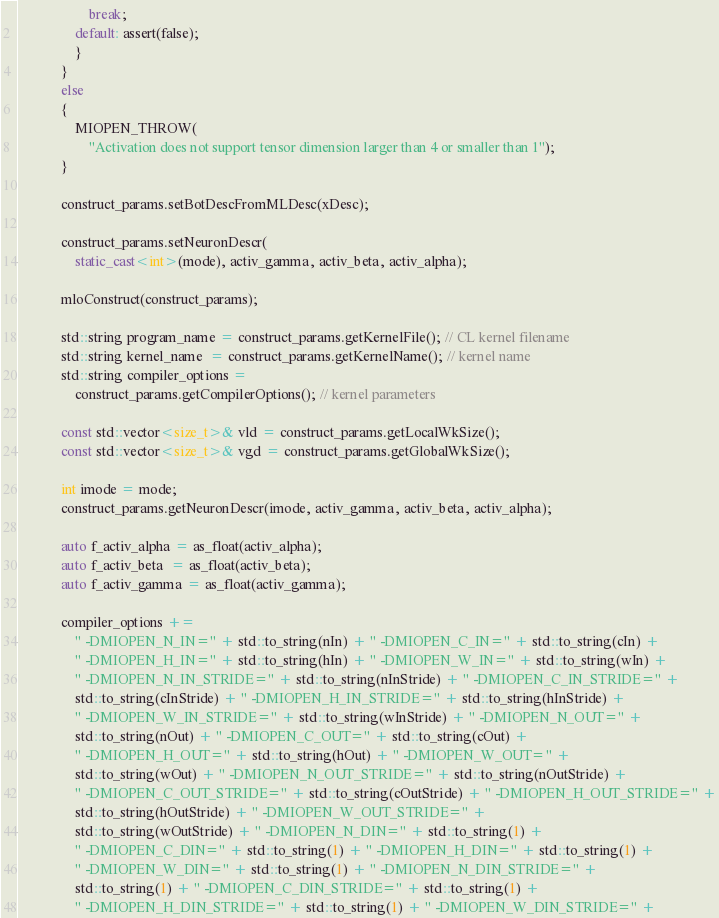<code> <loc_0><loc_0><loc_500><loc_500><_C++_>                    break;
                default: assert(false);
                }
            }
            else
            {
                MIOPEN_THROW(
                    "Activation does not support tensor dimension larger than 4 or smaller than 1");
            }

            construct_params.setBotDescFromMLDesc(xDesc);

            construct_params.setNeuronDescr(
                static_cast<int>(mode), activ_gamma, activ_beta, activ_alpha);

            mloConstruct(construct_params);

            std::string program_name = construct_params.getKernelFile(); // CL kernel filename
            std::string kernel_name  = construct_params.getKernelName(); // kernel name
            std::string compiler_options =
                construct_params.getCompilerOptions(); // kernel parameters

            const std::vector<size_t>& vld = construct_params.getLocalWkSize();
            const std::vector<size_t>& vgd = construct_params.getGlobalWkSize();

            int imode = mode;
            construct_params.getNeuronDescr(imode, activ_gamma, activ_beta, activ_alpha);

            auto f_activ_alpha = as_float(activ_alpha);
            auto f_activ_beta  = as_float(activ_beta);
            auto f_activ_gamma = as_float(activ_gamma);

            compiler_options +=
                " -DMIOPEN_N_IN=" + std::to_string(nIn) + " -DMIOPEN_C_IN=" + std::to_string(cIn) +
                " -DMIOPEN_H_IN=" + std::to_string(hIn) + " -DMIOPEN_W_IN=" + std::to_string(wIn) +
                " -DMIOPEN_N_IN_STRIDE=" + std::to_string(nInStride) + " -DMIOPEN_C_IN_STRIDE=" +
                std::to_string(cInStride) + " -DMIOPEN_H_IN_STRIDE=" + std::to_string(hInStride) +
                " -DMIOPEN_W_IN_STRIDE=" + std::to_string(wInStride) + " -DMIOPEN_N_OUT=" +
                std::to_string(nOut) + " -DMIOPEN_C_OUT=" + std::to_string(cOut) +
                " -DMIOPEN_H_OUT=" + std::to_string(hOut) + " -DMIOPEN_W_OUT=" +
                std::to_string(wOut) + " -DMIOPEN_N_OUT_STRIDE=" + std::to_string(nOutStride) +
                " -DMIOPEN_C_OUT_STRIDE=" + std::to_string(cOutStride) + " -DMIOPEN_H_OUT_STRIDE=" +
                std::to_string(hOutStride) + " -DMIOPEN_W_OUT_STRIDE=" +
                std::to_string(wOutStride) + " -DMIOPEN_N_DIN=" + std::to_string(1) +
                " -DMIOPEN_C_DIN=" + std::to_string(1) + " -DMIOPEN_H_DIN=" + std::to_string(1) +
                " -DMIOPEN_W_DIN=" + std::to_string(1) + " -DMIOPEN_N_DIN_STRIDE=" +
                std::to_string(1) + " -DMIOPEN_C_DIN_STRIDE=" + std::to_string(1) +
                " -DMIOPEN_H_DIN_STRIDE=" + std::to_string(1) + " -DMIOPEN_W_DIN_STRIDE=" +</code> 